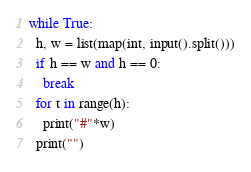<code> <loc_0><loc_0><loc_500><loc_500><_Python_>while True:
  h, w = list(map(int, input().split()))
  if h == w and h == 0:
    break
  for t in range(h):
    print("#"*w)
  print("")
</code> 